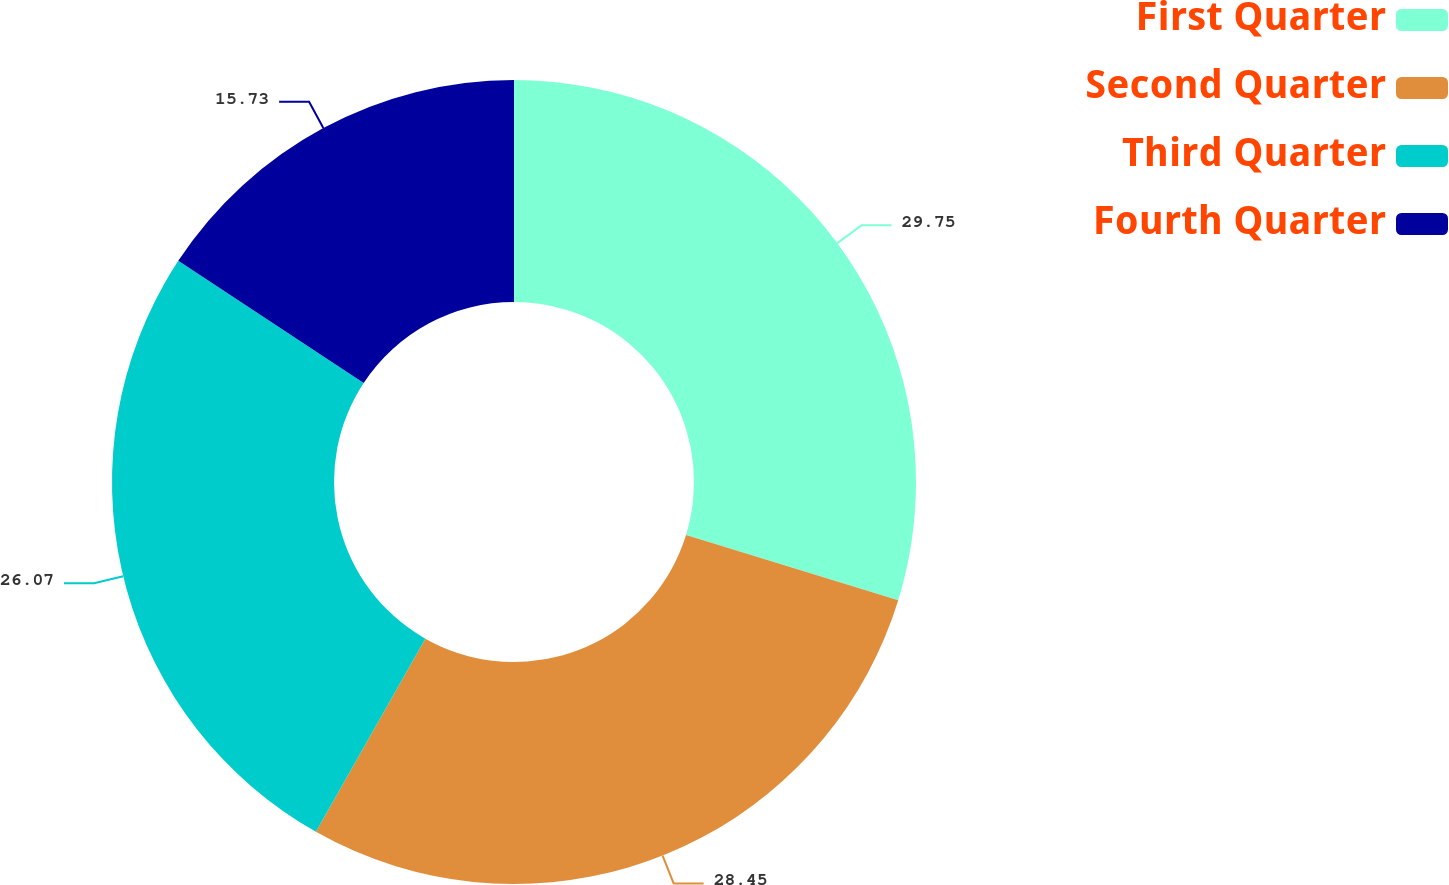Convert chart. <chart><loc_0><loc_0><loc_500><loc_500><pie_chart><fcel>First Quarter<fcel>Second Quarter<fcel>Third Quarter<fcel>Fourth Quarter<nl><fcel>29.75%<fcel>28.45%<fcel>26.07%<fcel>15.73%<nl></chart> 